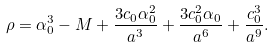<formula> <loc_0><loc_0><loc_500><loc_500>\rho = \alpha _ { 0 } ^ { 3 } - M + \frac { 3 c _ { 0 } \alpha _ { 0 } ^ { 2 } } { a ^ { 3 } } + \frac { 3 c _ { 0 } ^ { 2 } \alpha _ { 0 } } { a ^ { 6 } } + \frac { c _ { 0 } ^ { 3 } } { a ^ { 9 } } .</formula> 